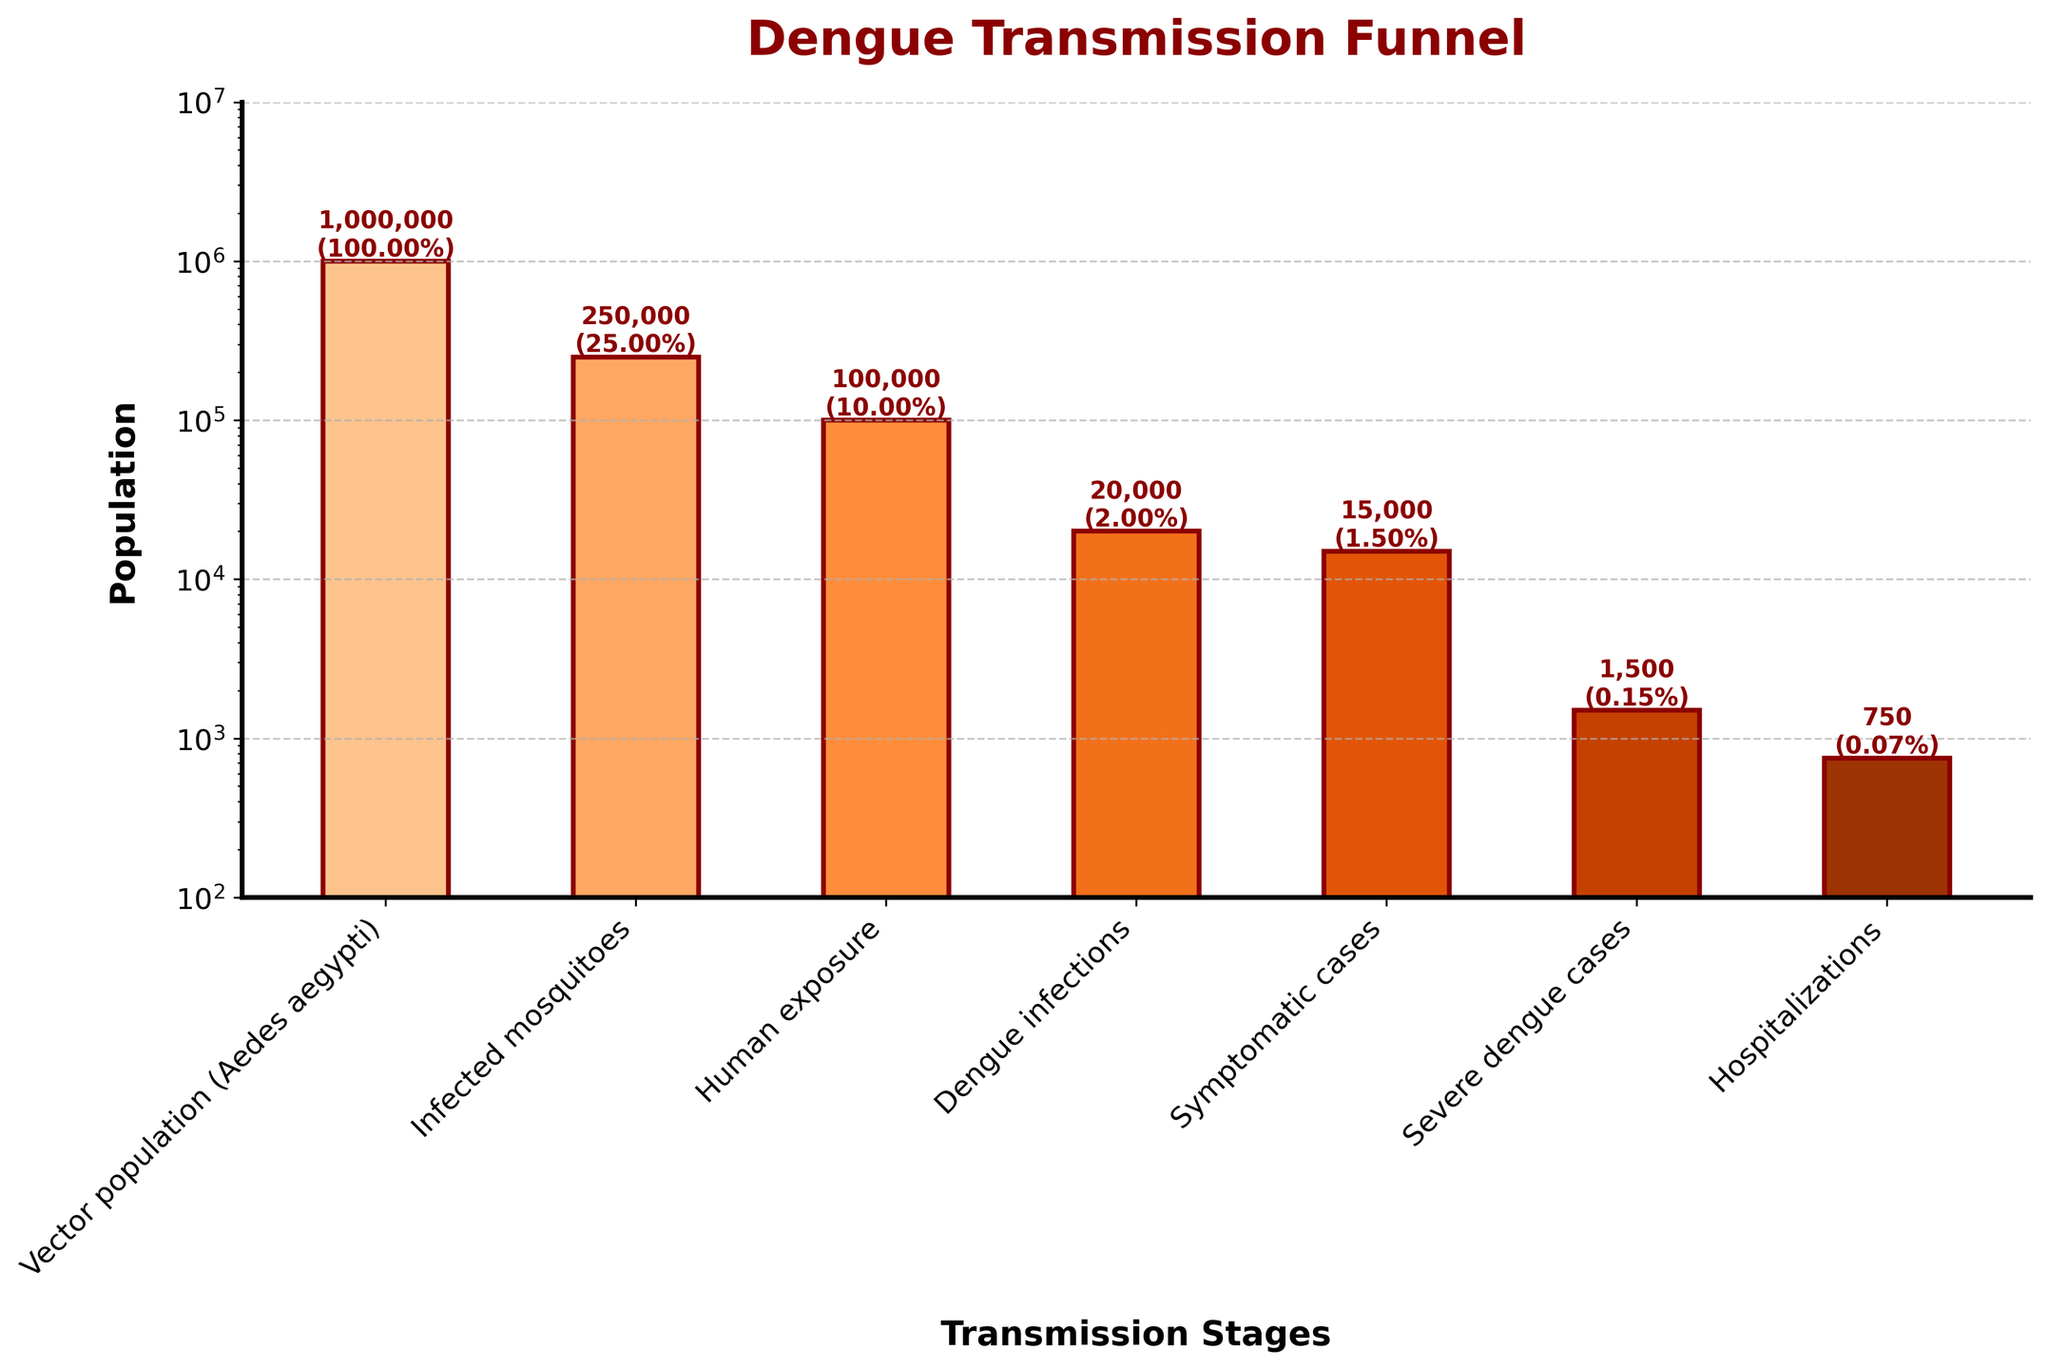What's the title of the plot? The title is located at the top of the plot. It is presented in bold, dark red text.
Answer: Dengue Transmission Funnel What's the approximate population of infected mosquitoes? The population of infected mosquitoes is labeled directly above the respective bar.
Answer: 250,000 What percentage of the vector population (Aedes aegypti) becomes infected mosquitoes? The percentage is annotated above the "Infected mosquitoes" bar.
Answer: 25% Which stage has the lowest population? By looking at the height of the bars, the shortest one indicates the lowest population.
Answer: Hospitalizations How many stages are represented in the Funnel Chart? The number of distinct bars corresponds to the number of stages. Count the bars.
Answer: 7 Which stage shows the largest drop in population compared to the previous stage? Compare the differences in population heights between stages. The largest drop occurs between "Infected mosquitoes" and "Human exposure".
Answer: From Infected mosquitoes to Human exposure What is the population of symptomatic cases? Look for the bar labeled "Symptomatic cases" and read off the population annotated there.
Answer: 15,000 What is the ratio of hospitalized cases to severe dengue cases? Divide the population of hospitalizations by the population of severe dengue cases.
Answer: 750 / 1,500 = 0.5 By how much does the population decrease from severe dengue cases to hospitalizations? Subtract the hospitalization population from the severe dengue cases population.
Answer: 1,500 - 750 = 750 Which stage sees the greatest proportional drop in percentage? Compare the percentages annotated above each stage. The greatest proportional drop is between "Human exposure" and "Dengue infections".
Answer: From Human exposure to Dengue infections 